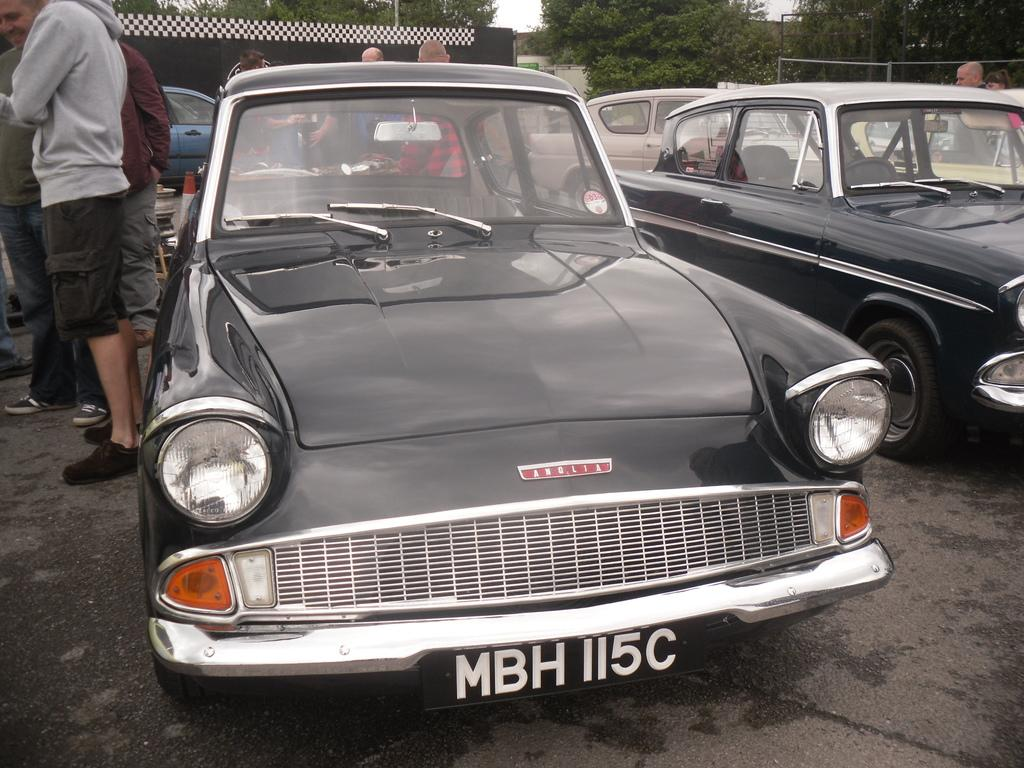What type of vehicles can be seen in the image? There are cars in the image. What else is present in the image besides cars? There are people standing and trees in the image. Can you describe the structure in the image? There is a house in the image. What type of connection can be seen between the people and the ladybug in the image? There is no ladybug present in the image, so there is no connection between the people and a ladybug. 